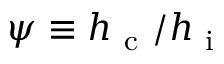Convert formula to latex. <formula><loc_0><loc_0><loc_500><loc_500>\psi \equiv h _ { c } / h _ { i }</formula> 